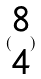<formula> <loc_0><loc_0><loc_500><loc_500>( \begin{matrix} 8 \\ 4 \end{matrix} )</formula> 